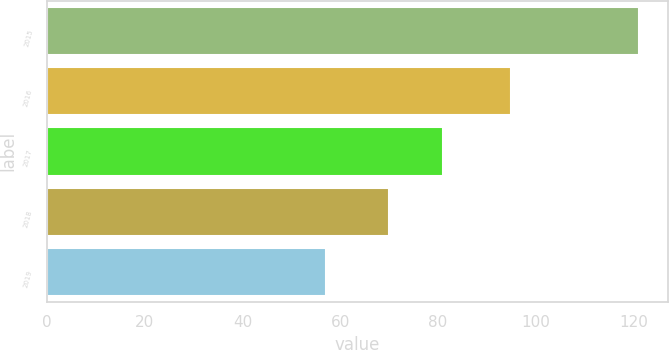Convert chart to OTSL. <chart><loc_0><loc_0><loc_500><loc_500><bar_chart><fcel>2015<fcel>2016<fcel>2017<fcel>2018<fcel>2019<nl><fcel>121<fcel>95<fcel>81<fcel>70<fcel>57<nl></chart> 